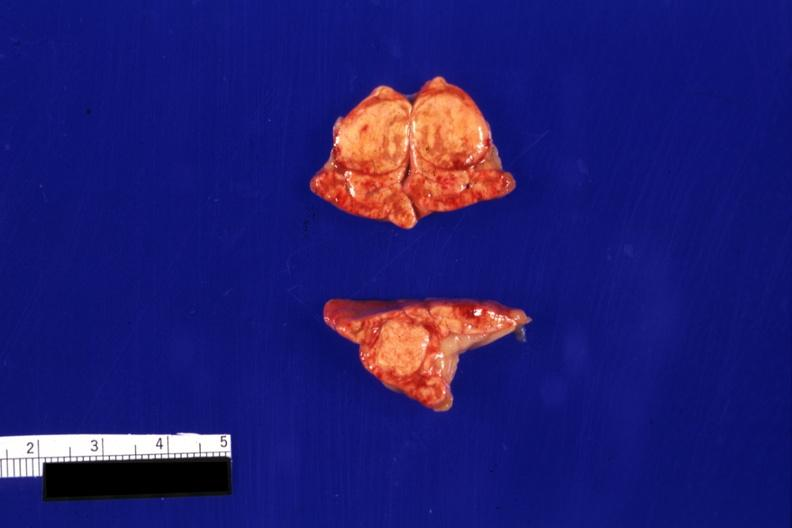does this image show typical so-called cortical adenomas?
Answer the question using a single word or phrase. Yes 